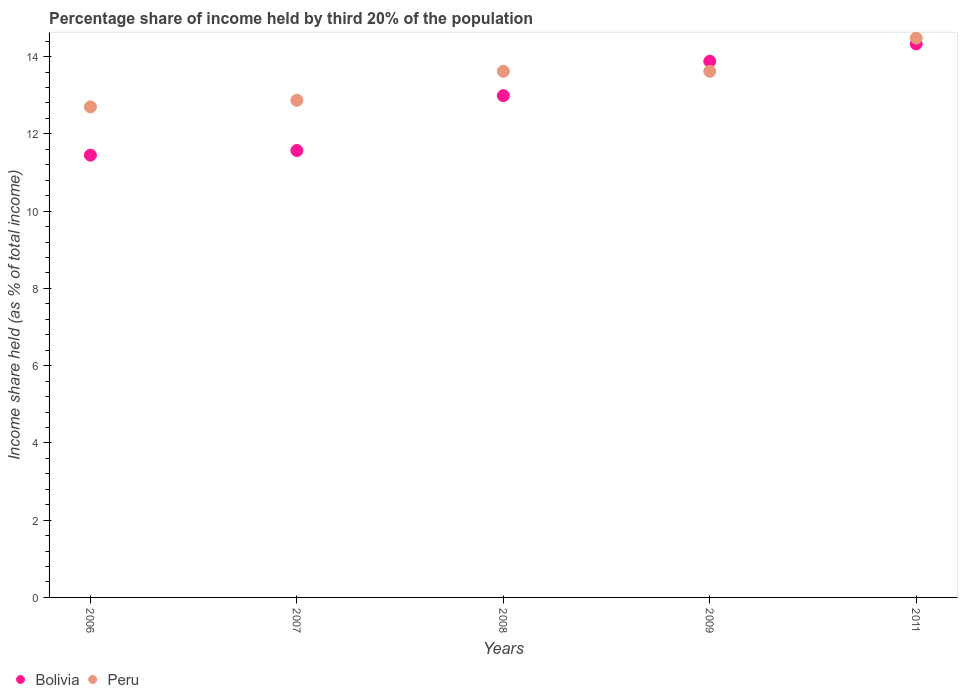Is the number of dotlines equal to the number of legend labels?
Give a very brief answer. Yes. What is the share of income held by third 20% of the population in Bolivia in 2006?
Provide a succinct answer. 11.45. Across all years, what is the maximum share of income held by third 20% of the population in Bolivia?
Your response must be concise. 14.33. Across all years, what is the minimum share of income held by third 20% of the population in Peru?
Your answer should be very brief. 12.7. In which year was the share of income held by third 20% of the population in Bolivia minimum?
Your response must be concise. 2006. What is the total share of income held by third 20% of the population in Peru in the graph?
Provide a short and direct response. 67.29. What is the difference between the share of income held by third 20% of the population in Bolivia in 2008 and that in 2009?
Your answer should be very brief. -0.89. What is the difference between the share of income held by third 20% of the population in Bolivia in 2006 and the share of income held by third 20% of the population in Peru in 2008?
Your response must be concise. -2.17. What is the average share of income held by third 20% of the population in Bolivia per year?
Ensure brevity in your answer.  12.84. In the year 2011, what is the difference between the share of income held by third 20% of the population in Bolivia and share of income held by third 20% of the population in Peru?
Your answer should be very brief. -0.15. What is the ratio of the share of income held by third 20% of the population in Peru in 2009 to that in 2011?
Give a very brief answer. 0.94. Is the difference between the share of income held by third 20% of the population in Bolivia in 2007 and 2009 greater than the difference between the share of income held by third 20% of the population in Peru in 2007 and 2009?
Ensure brevity in your answer.  No. What is the difference between the highest and the second highest share of income held by third 20% of the population in Peru?
Offer a very short reply. 0.86. What is the difference between the highest and the lowest share of income held by third 20% of the population in Peru?
Give a very brief answer. 1.78. In how many years, is the share of income held by third 20% of the population in Bolivia greater than the average share of income held by third 20% of the population in Bolivia taken over all years?
Your answer should be compact. 3. Is the sum of the share of income held by third 20% of the population in Bolivia in 2006 and 2009 greater than the maximum share of income held by third 20% of the population in Peru across all years?
Make the answer very short. Yes. Does the share of income held by third 20% of the population in Bolivia monotonically increase over the years?
Provide a succinct answer. Yes. Is the share of income held by third 20% of the population in Peru strictly greater than the share of income held by third 20% of the population in Bolivia over the years?
Make the answer very short. No. Is the share of income held by third 20% of the population in Bolivia strictly less than the share of income held by third 20% of the population in Peru over the years?
Keep it short and to the point. No. What is the title of the graph?
Provide a short and direct response. Percentage share of income held by third 20% of the population. What is the label or title of the Y-axis?
Offer a terse response. Income share held (as % of total income). What is the Income share held (as % of total income) of Bolivia in 2006?
Provide a succinct answer. 11.45. What is the Income share held (as % of total income) in Peru in 2006?
Keep it short and to the point. 12.7. What is the Income share held (as % of total income) in Bolivia in 2007?
Your answer should be compact. 11.57. What is the Income share held (as % of total income) of Peru in 2007?
Give a very brief answer. 12.87. What is the Income share held (as % of total income) in Bolivia in 2008?
Offer a terse response. 12.99. What is the Income share held (as % of total income) in Peru in 2008?
Provide a succinct answer. 13.62. What is the Income share held (as % of total income) in Bolivia in 2009?
Make the answer very short. 13.88. What is the Income share held (as % of total income) in Peru in 2009?
Your response must be concise. 13.62. What is the Income share held (as % of total income) in Bolivia in 2011?
Provide a short and direct response. 14.33. What is the Income share held (as % of total income) of Peru in 2011?
Ensure brevity in your answer.  14.48. Across all years, what is the maximum Income share held (as % of total income) of Bolivia?
Your answer should be compact. 14.33. Across all years, what is the maximum Income share held (as % of total income) of Peru?
Your response must be concise. 14.48. Across all years, what is the minimum Income share held (as % of total income) in Bolivia?
Your response must be concise. 11.45. What is the total Income share held (as % of total income) in Bolivia in the graph?
Your answer should be compact. 64.22. What is the total Income share held (as % of total income) in Peru in the graph?
Offer a very short reply. 67.29. What is the difference between the Income share held (as % of total income) in Bolivia in 2006 and that in 2007?
Provide a short and direct response. -0.12. What is the difference between the Income share held (as % of total income) in Peru in 2006 and that in 2007?
Give a very brief answer. -0.17. What is the difference between the Income share held (as % of total income) in Bolivia in 2006 and that in 2008?
Offer a terse response. -1.54. What is the difference between the Income share held (as % of total income) in Peru in 2006 and that in 2008?
Offer a very short reply. -0.92. What is the difference between the Income share held (as % of total income) of Bolivia in 2006 and that in 2009?
Your answer should be compact. -2.43. What is the difference between the Income share held (as % of total income) of Peru in 2006 and that in 2009?
Offer a very short reply. -0.92. What is the difference between the Income share held (as % of total income) in Bolivia in 2006 and that in 2011?
Offer a terse response. -2.88. What is the difference between the Income share held (as % of total income) in Peru in 2006 and that in 2011?
Offer a very short reply. -1.78. What is the difference between the Income share held (as % of total income) in Bolivia in 2007 and that in 2008?
Keep it short and to the point. -1.42. What is the difference between the Income share held (as % of total income) of Peru in 2007 and that in 2008?
Offer a terse response. -0.75. What is the difference between the Income share held (as % of total income) of Bolivia in 2007 and that in 2009?
Offer a terse response. -2.31. What is the difference between the Income share held (as % of total income) of Peru in 2007 and that in 2009?
Offer a terse response. -0.75. What is the difference between the Income share held (as % of total income) in Bolivia in 2007 and that in 2011?
Your response must be concise. -2.76. What is the difference between the Income share held (as % of total income) in Peru in 2007 and that in 2011?
Offer a very short reply. -1.61. What is the difference between the Income share held (as % of total income) in Bolivia in 2008 and that in 2009?
Your answer should be very brief. -0.89. What is the difference between the Income share held (as % of total income) of Bolivia in 2008 and that in 2011?
Give a very brief answer. -1.34. What is the difference between the Income share held (as % of total income) in Peru in 2008 and that in 2011?
Provide a succinct answer. -0.86. What is the difference between the Income share held (as % of total income) in Bolivia in 2009 and that in 2011?
Offer a terse response. -0.45. What is the difference between the Income share held (as % of total income) of Peru in 2009 and that in 2011?
Give a very brief answer. -0.86. What is the difference between the Income share held (as % of total income) of Bolivia in 2006 and the Income share held (as % of total income) of Peru in 2007?
Your answer should be very brief. -1.42. What is the difference between the Income share held (as % of total income) of Bolivia in 2006 and the Income share held (as % of total income) of Peru in 2008?
Provide a succinct answer. -2.17. What is the difference between the Income share held (as % of total income) of Bolivia in 2006 and the Income share held (as % of total income) of Peru in 2009?
Your answer should be compact. -2.17. What is the difference between the Income share held (as % of total income) in Bolivia in 2006 and the Income share held (as % of total income) in Peru in 2011?
Your answer should be very brief. -3.03. What is the difference between the Income share held (as % of total income) of Bolivia in 2007 and the Income share held (as % of total income) of Peru in 2008?
Provide a succinct answer. -2.05. What is the difference between the Income share held (as % of total income) in Bolivia in 2007 and the Income share held (as % of total income) in Peru in 2009?
Make the answer very short. -2.05. What is the difference between the Income share held (as % of total income) in Bolivia in 2007 and the Income share held (as % of total income) in Peru in 2011?
Make the answer very short. -2.91. What is the difference between the Income share held (as % of total income) of Bolivia in 2008 and the Income share held (as % of total income) of Peru in 2009?
Offer a very short reply. -0.63. What is the difference between the Income share held (as % of total income) in Bolivia in 2008 and the Income share held (as % of total income) in Peru in 2011?
Provide a short and direct response. -1.49. What is the average Income share held (as % of total income) in Bolivia per year?
Your answer should be compact. 12.84. What is the average Income share held (as % of total income) in Peru per year?
Make the answer very short. 13.46. In the year 2006, what is the difference between the Income share held (as % of total income) of Bolivia and Income share held (as % of total income) of Peru?
Provide a succinct answer. -1.25. In the year 2007, what is the difference between the Income share held (as % of total income) of Bolivia and Income share held (as % of total income) of Peru?
Your response must be concise. -1.3. In the year 2008, what is the difference between the Income share held (as % of total income) of Bolivia and Income share held (as % of total income) of Peru?
Your response must be concise. -0.63. In the year 2009, what is the difference between the Income share held (as % of total income) of Bolivia and Income share held (as % of total income) of Peru?
Your response must be concise. 0.26. What is the ratio of the Income share held (as % of total income) of Bolivia in 2006 to that in 2007?
Keep it short and to the point. 0.99. What is the ratio of the Income share held (as % of total income) of Bolivia in 2006 to that in 2008?
Provide a succinct answer. 0.88. What is the ratio of the Income share held (as % of total income) in Peru in 2006 to that in 2008?
Ensure brevity in your answer.  0.93. What is the ratio of the Income share held (as % of total income) of Bolivia in 2006 to that in 2009?
Make the answer very short. 0.82. What is the ratio of the Income share held (as % of total income) of Peru in 2006 to that in 2009?
Keep it short and to the point. 0.93. What is the ratio of the Income share held (as % of total income) in Bolivia in 2006 to that in 2011?
Make the answer very short. 0.8. What is the ratio of the Income share held (as % of total income) of Peru in 2006 to that in 2011?
Provide a short and direct response. 0.88. What is the ratio of the Income share held (as % of total income) in Bolivia in 2007 to that in 2008?
Provide a short and direct response. 0.89. What is the ratio of the Income share held (as % of total income) in Peru in 2007 to that in 2008?
Provide a succinct answer. 0.94. What is the ratio of the Income share held (as % of total income) of Bolivia in 2007 to that in 2009?
Provide a succinct answer. 0.83. What is the ratio of the Income share held (as % of total income) in Peru in 2007 to that in 2009?
Offer a very short reply. 0.94. What is the ratio of the Income share held (as % of total income) of Bolivia in 2007 to that in 2011?
Offer a very short reply. 0.81. What is the ratio of the Income share held (as % of total income) of Peru in 2007 to that in 2011?
Offer a very short reply. 0.89. What is the ratio of the Income share held (as % of total income) in Bolivia in 2008 to that in 2009?
Provide a succinct answer. 0.94. What is the ratio of the Income share held (as % of total income) in Peru in 2008 to that in 2009?
Offer a very short reply. 1. What is the ratio of the Income share held (as % of total income) of Bolivia in 2008 to that in 2011?
Ensure brevity in your answer.  0.91. What is the ratio of the Income share held (as % of total income) of Peru in 2008 to that in 2011?
Provide a succinct answer. 0.94. What is the ratio of the Income share held (as % of total income) of Bolivia in 2009 to that in 2011?
Keep it short and to the point. 0.97. What is the ratio of the Income share held (as % of total income) in Peru in 2009 to that in 2011?
Your answer should be compact. 0.94. What is the difference between the highest and the second highest Income share held (as % of total income) in Bolivia?
Offer a terse response. 0.45. What is the difference between the highest and the second highest Income share held (as % of total income) of Peru?
Keep it short and to the point. 0.86. What is the difference between the highest and the lowest Income share held (as % of total income) of Bolivia?
Provide a succinct answer. 2.88. What is the difference between the highest and the lowest Income share held (as % of total income) in Peru?
Offer a terse response. 1.78. 